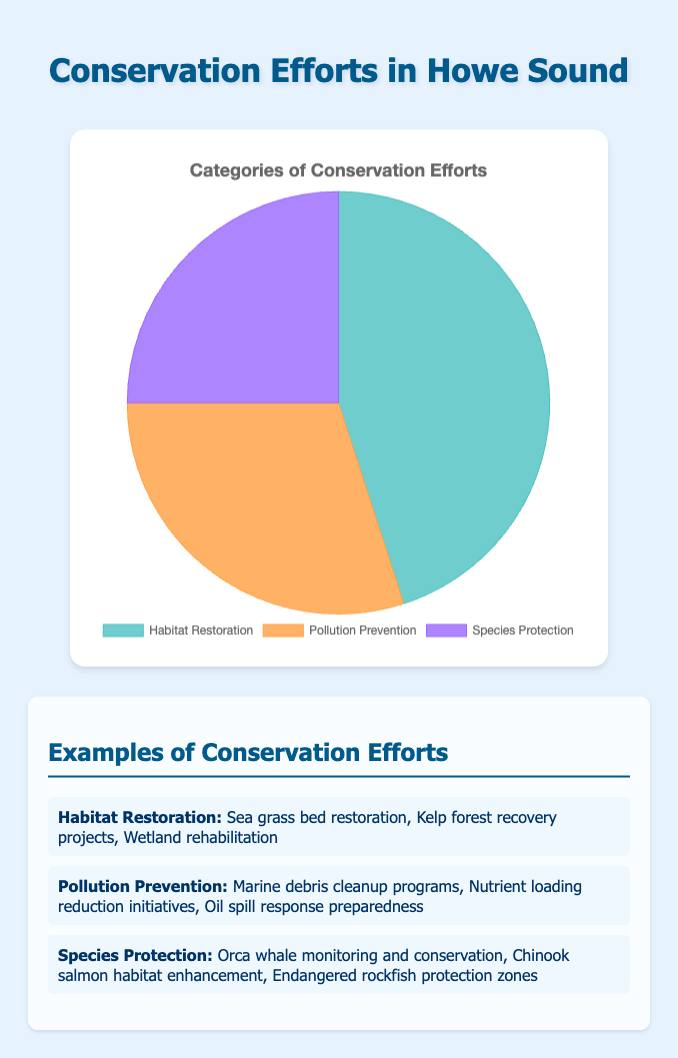What category of conservation efforts has the largest percentage? The pie chart shows three categories: Habitat Restoration, Pollution Prevention, and Species Protection, with the corresponding percentages of 45%, 30%, and 25%. Habitat Restoration has the largest percentage.
Answer: Habitat Restoration Which category has the smallest percentage? The pie chart displays three categories with their respective percentages. Species Protection, at 25%, is the smallest percentage among the three.
Answer: Species Protection What is the combined percentage of Pollution Prevention and Species Protection efforts? Adding the percentages of Pollution Prevention (30%) and Species Protection (25%) gives 30% + 25% = 55%.
Answer: 55% Is the percentage of Habitat Restoration efforts greater than or equal to the combined percentage of Pollution Prevention and Species Protection efforts? Habitat Restoration is 45%, while the sum of Pollution Prevention and Species Protection is 30% + 25% = 55%. Therefore, Habitat Restoration is not greater than or equal to the combined percentage.
Answer: No How much more effort (in percentage points) is put into Habitat Restoration compared to Species Protection? Subtract the percentage for Species Protection (25%) from Habitat Restoration (45%): 45% - 25% = 20%.
Answer: 20% Which category contributes 30% to the conservation efforts as seen in the chart? The pie chart shows Pollution Prevention at 30%.
Answer: Pollution Prevention By looking at the pie chart colors, which color represents the category with the second largest percentage? The second largest percentage is for Pollution Prevention at 30%, and the chart indicates this category is represented by an orange color.
Answer: Orange If efforts were to be equally distributed, what percentage would each category have? The pie chart has three categories. Dividing 100% by 3 gives approximately 33.33% for each category.
Answer: Approximately 33.33% If Habitat Restoration efforts were reduced by 10%, how would the new percentage compare to Pollution Prevention efforts? Reducing Habitat Restoration by 10% results in 45% - 10% = 35%. Pollution Prevention is 30%. Therefore, the new percentage for Habitat Restoration would still be greater than Pollution Prevention.
Answer: 35% > 30% What is the combined total of all conservation efforts? Adding all three conservation efforts: Habitat Restoration (45%), Pollution Prevention (30%), and Species Protection (25%) gives 45% + 30% + 25% = 100%.
Answer: 100% 